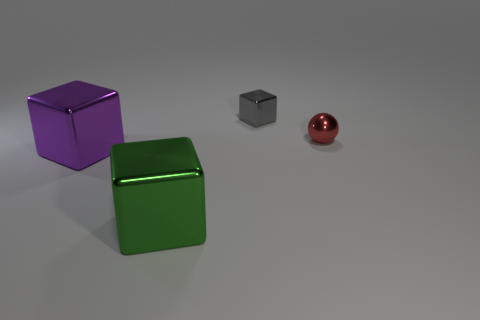Subtract all tiny cubes. How many cubes are left? 2 Subtract all gray blocks. How many blocks are left? 2 Subtract all blocks. How many objects are left? 1 Add 2 small cubes. How many small cubes exist? 3 Add 4 green objects. How many objects exist? 8 Subtract 0 yellow spheres. How many objects are left? 4 Subtract all cyan cubes. Subtract all purple cylinders. How many cubes are left? 3 Subtract all gray cylinders. How many blue cubes are left? 0 Subtract all red metallic objects. Subtract all metal blocks. How many objects are left? 0 Add 1 small spheres. How many small spheres are left? 2 